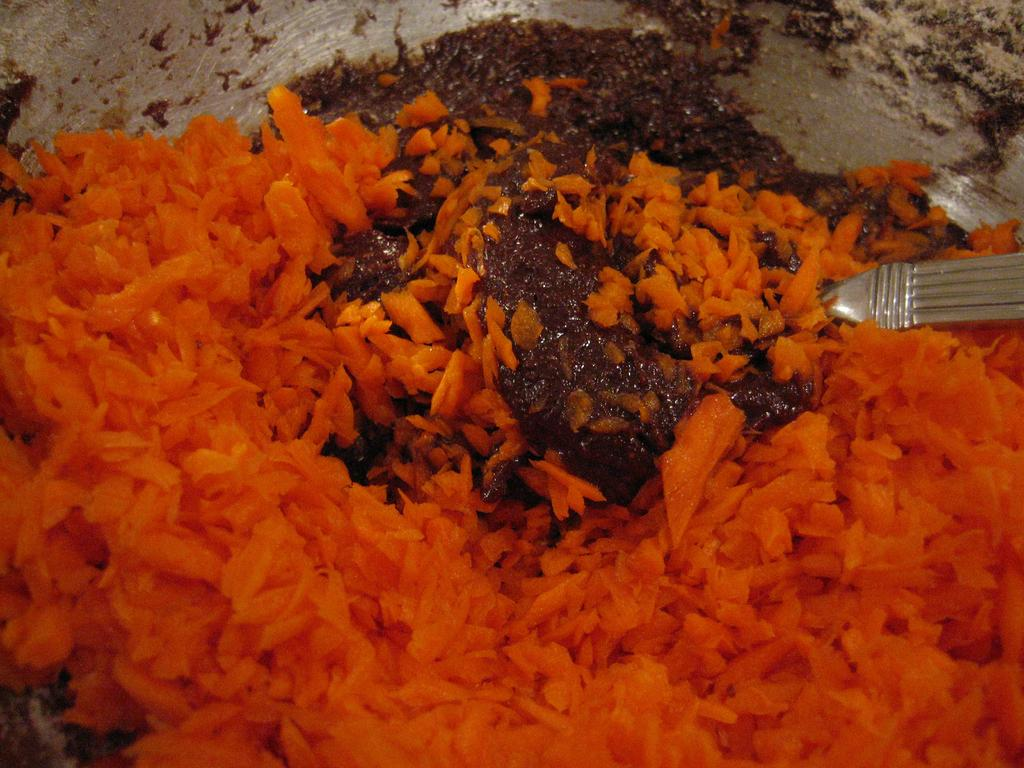What is happening in the image? There is a food item being prepared in the image. What specific ingredient is being used in the preparation of the food item? Carrots are involved in the preparation of the food item. Where is the bedroom located in the image? There is no bedroom present in the image; it features the preparation of a food item involving carrots. What type of tool is being used to lift the carrots in the image? There is no tool or lifting action involved in the preparation of the food item in the image; it simply shows carrots being used. 